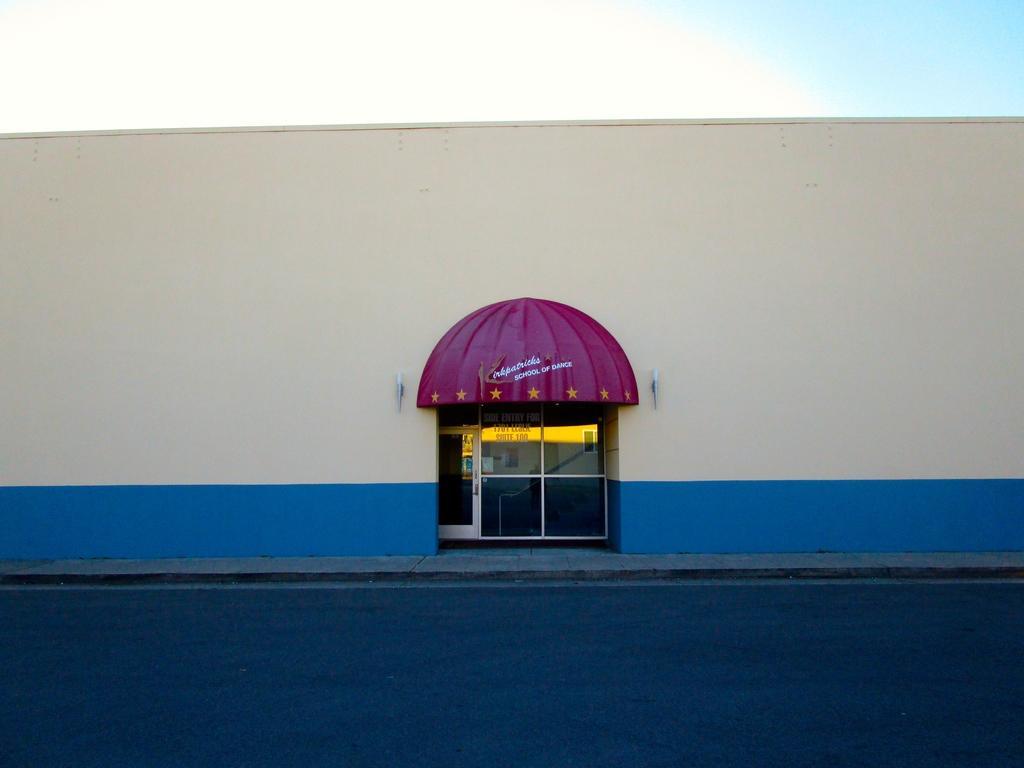Could you give a brief overview of what you see in this image? In this image in the front there is road. In the background there is a wall and on the wall there is a window, there is a tent in front of the wall with some text written on it in the sky is cloudy. 